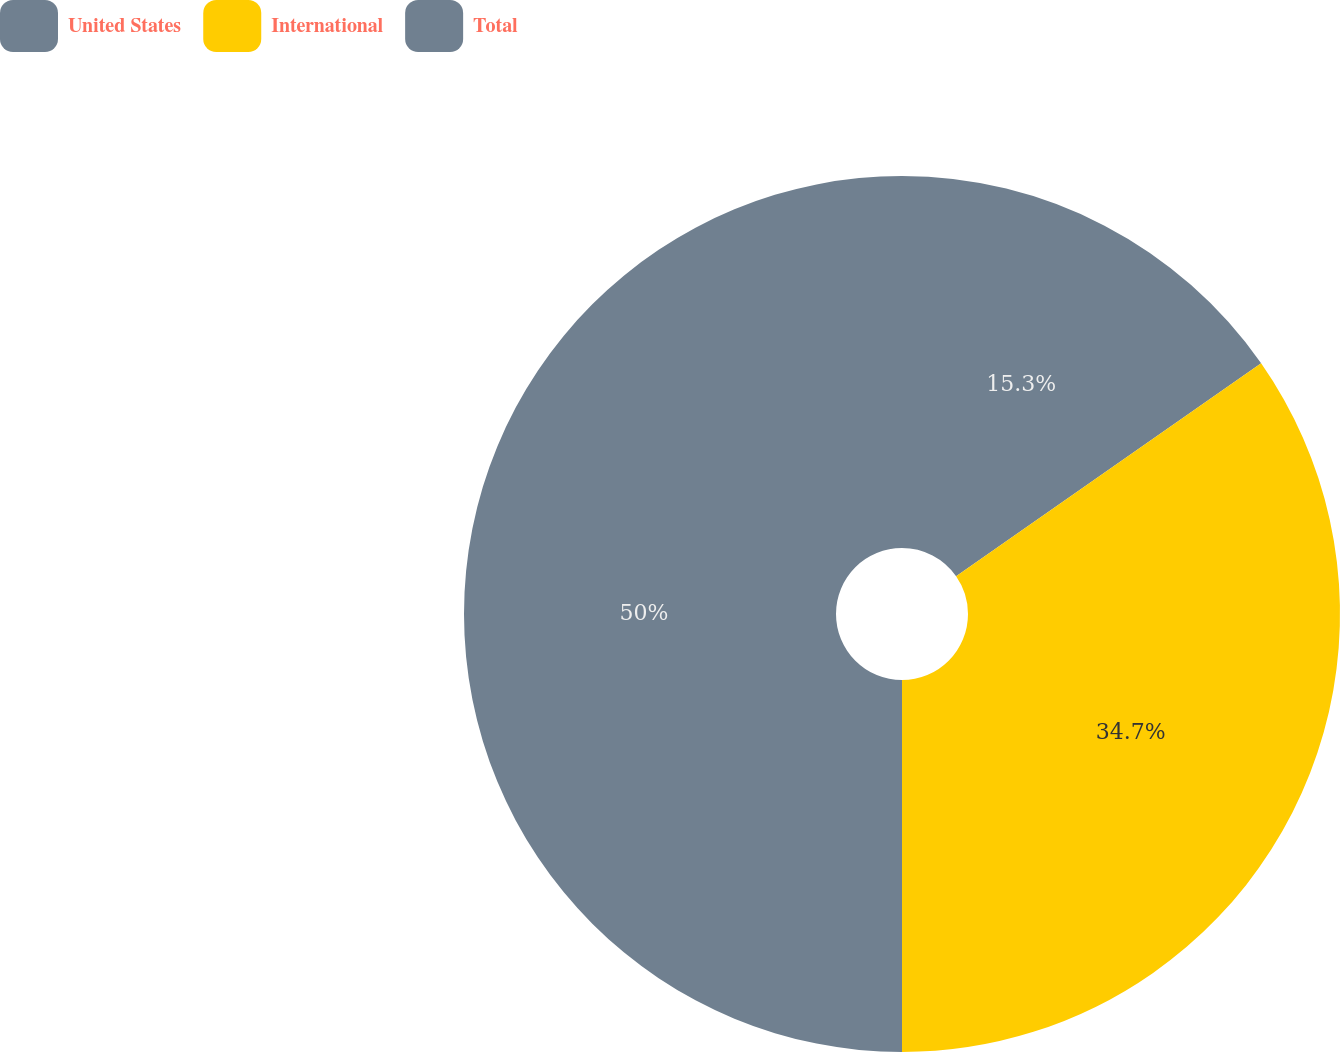Convert chart to OTSL. <chart><loc_0><loc_0><loc_500><loc_500><pie_chart><fcel>United States<fcel>International<fcel>Total<nl><fcel>15.3%<fcel>34.7%<fcel>50.0%<nl></chart> 